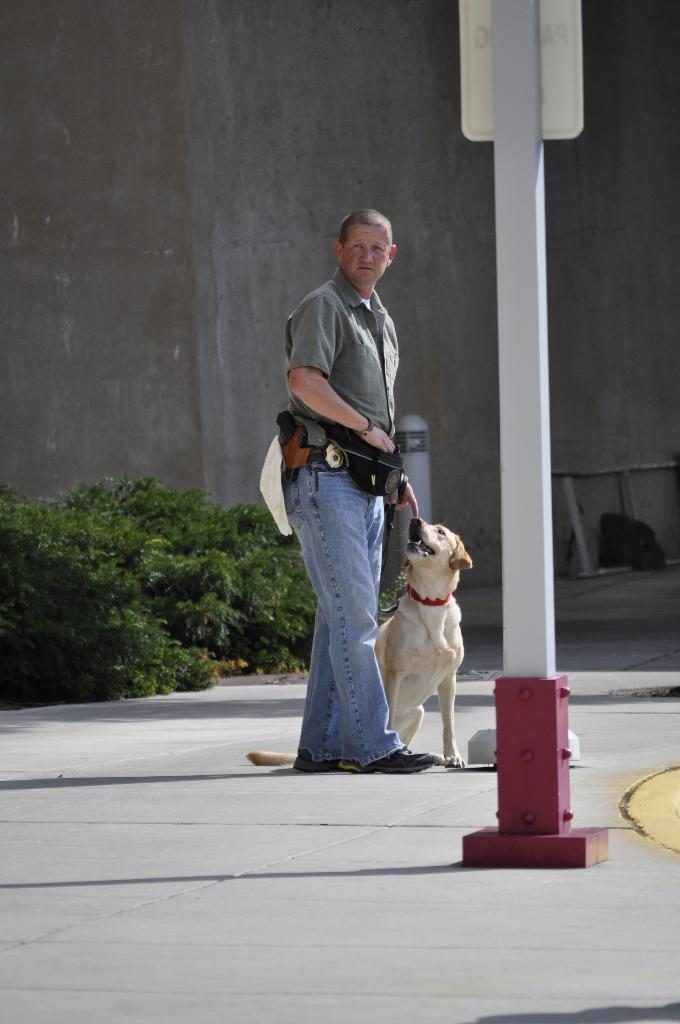What is happening in the image involving a man? The man is catching a dog in the image. Where does the scene take place? The scene takes place in the street. What can be seen in the background of the image? There is a pole, a name board, plants, and a building in the background of the image. What type of quince is being used to train the dogs in the image? There is no quince present in the image, nor are there any dogs being trained. 